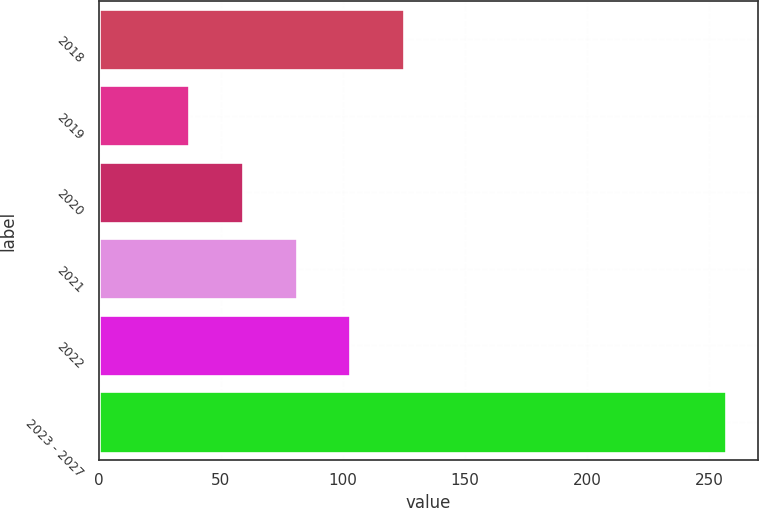Convert chart to OTSL. <chart><loc_0><loc_0><loc_500><loc_500><bar_chart><fcel>2018<fcel>2019<fcel>2020<fcel>2021<fcel>2022<fcel>2023 - 2027<nl><fcel>125<fcel>37<fcel>59<fcel>81<fcel>103<fcel>257<nl></chart> 